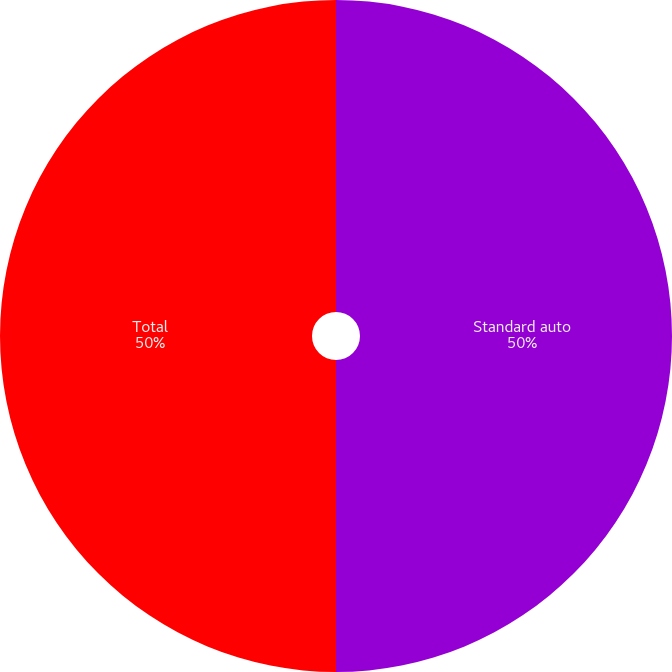<chart> <loc_0><loc_0><loc_500><loc_500><pie_chart><fcel>Standard auto<fcel>Total<nl><fcel>50.0%<fcel>50.0%<nl></chart> 